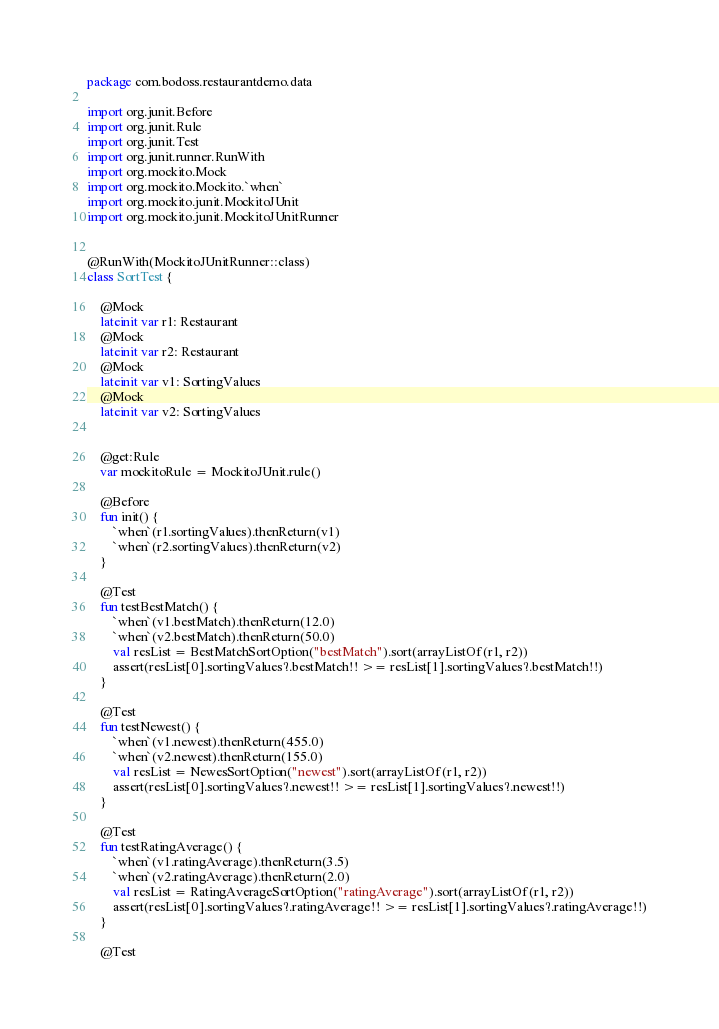Convert code to text. <code><loc_0><loc_0><loc_500><loc_500><_Kotlin_>package com.bodoss.restaurantdemo.data

import org.junit.Before
import org.junit.Rule
import org.junit.Test
import org.junit.runner.RunWith
import org.mockito.Mock
import org.mockito.Mockito.`when`
import org.mockito.junit.MockitoJUnit
import org.mockito.junit.MockitoJUnitRunner


@RunWith(MockitoJUnitRunner::class)
class SortTest {

    @Mock
    lateinit var r1: Restaurant
    @Mock
    lateinit var r2: Restaurant
    @Mock
    lateinit var v1: SortingValues
    @Mock
    lateinit var v2: SortingValues


    @get:Rule
    var mockitoRule = MockitoJUnit.rule()

    @Before
    fun init() {
        `when`(r1.sortingValues).thenReturn(v1)
        `when`(r2.sortingValues).thenReturn(v2)
    }

    @Test
    fun testBestMatch() {
        `when`(v1.bestMatch).thenReturn(12.0)
        `when`(v2.bestMatch).thenReturn(50.0)
        val resList = BestMatchSortOption("bestMatch").sort(arrayListOf(r1, r2))
        assert(resList[0].sortingValues?.bestMatch!! >= resList[1].sortingValues?.bestMatch!!)
    }

    @Test
    fun testNewest() {
        `when`(v1.newest).thenReturn(455.0)
        `when`(v2.newest).thenReturn(155.0)
        val resList = NewesSortOption("newest").sort(arrayListOf(r1, r2))
        assert(resList[0].sortingValues?.newest!! >= resList[1].sortingValues?.newest!!)
    }

    @Test
    fun testRatingAverage() {
        `when`(v1.ratingAverage).thenReturn(3.5)
        `when`(v2.ratingAverage).thenReturn(2.0)
        val resList = RatingAverageSortOption("ratingAverage").sort(arrayListOf(r1, r2))
        assert(resList[0].sortingValues?.ratingAverage!! >= resList[1].sortingValues?.ratingAverage!!)
    }

    @Test</code> 